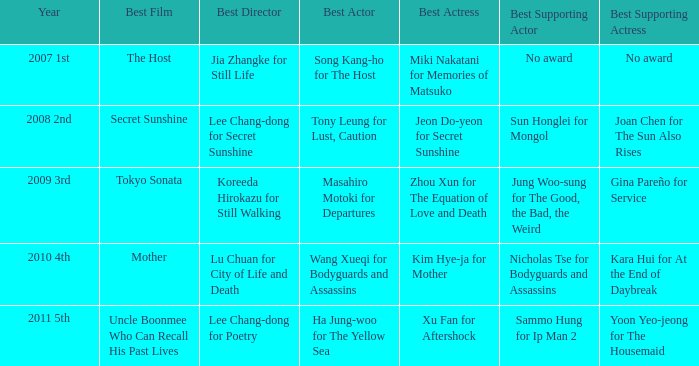Who is the most outstanding actor in uncle boonmee who can recollect his former lives? Ha Jung-woo for The Yellow Sea. Could you help me parse every detail presented in this table? {'header': ['Year', 'Best Film', 'Best Director', 'Best Actor', 'Best Actress', 'Best Supporting Actor', 'Best Supporting Actress'], 'rows': [['2007 1st', 'The Host', 'Jia Zhangke for Still Life', 'Song Kang-ho for The Host', 'Miki Nakatani for Memories of Matsuko', 'No award', 'No award'], ['2008 2nd', 'Secret Sunshine', 'Lee Chang-dong for Secret Sunshine', 'Tony Leung for Lust, Caution', 'Jeon Do-yeon for Secret Sunshine', 'Sun Honglei for Mongol', 'Joan Chen for The Sun Also Rises'], ['2009 3rd', 'Tokyo Sonata', 'Koreeda Hirokazu for Still Walking', 'Masahiro Motoki for Departures', 'Zhou Xun for The Equation of Love and Death', 'Jung Woo-sung for The Good, the Bad, the Weird', 'Gina Pareño for Service'], ['2010 4th', 'Mother', 'Lu Chuan for City of Life and Death', 'Wang Xueqi for Bodyguards and Assassins', 'Kim Hye-ja for Mother', 'Nicholas Tse for Bodyguards and Assassins', 'Kara Hui for At the End of Daybreak'], ['2011 5th', 'Uncle Boonmee Who Can Recall His Past Lives', 'Lee Chang-dong for Poetry', 'Ha Jung-woo for The Yellow Sea', 'Xu Fan for Aftershock', 'Sammo Hung for Ip Man 2', 'Yoon Yeo-jeong for The Housemaid']]} 